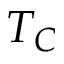<formula> <loc_0><loc_0><loc_500><loc_500>T _ { C }</formula> 